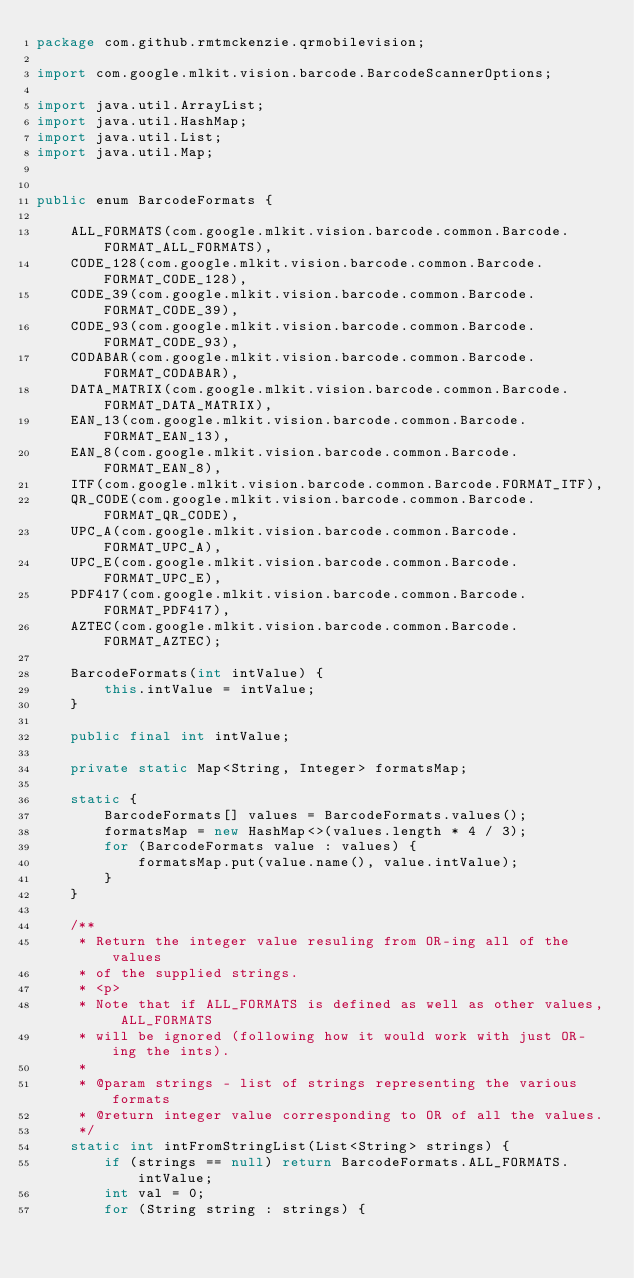<code> <loc_0><loc_0><loc_500><loc_500><_Java_>package com.github.rmtmckenzie.qrmobilevision;

import com.google.mlkit.vision.barcode.BarcodeScannerOptions;

import java.util.ArrayList;
import java.util.HashMap;
import java.util.List;
import java.util.Map;


public enum BarcodeFormats {

    ALL_FORMATS(com.google.mlkit.vision.barcode.common.Barcode.FORMAT_ALL_FORMATS),
    CODE_128(com.google.mlkit.vision.barcode.common.Barcode.FORMAT_CODE_128),
    CODE_39(com.google.mlkit.vision.barcode.common.Barcode.FORMAT_CODE_39),
    CODE_93(com.google.mlkit.vision.barcode.common.Barcode.FORMAT_CODE_93),
    CODABAR(com.google.mlkit.vision.barcode.common.Barcode.FORMAT_CODABAR),
    DATA_MATRIX(com.google.mlkit.vision.barcode.common.Barcode.FORMAT_DATA_MATRIX),
    EAN_13(com.google.mlkit.vision.barcode.common.Barcode.FORMAT_EAN_13),
    EAN_8(com.google.mlkit.vision.barcode.common.Barcode.FORMAT_EAN_8),
    ITF(com.google.mlkit.vision.barcode.common.Barcode.FORMAT_ITF),
    QR_CODE(com.google.mlkit.vision.barcode.common.Barcode.FORMAT_QR_CODE),
    UPC_A(com.google.mlkit.vision.barcode.common.Barcode.FORMAT_UPC_A),
    UPC_E(com.google.mlkit.vision.barcode.common.Barcode.FORMAT_UPC_E),
    PDF417(com.google.mlkit.vision.barcode.common.Barcode.FORMAT_PDF417),
    AZTEC(com.google.mlkit.vision.barcode.common.Barcode.FORMAT_AZTEC);

    BarcodeFormats(int intValue) {
        this.intValue = intValue;
    }

    public final int intValue;

    private static Map<String, Integer> formatsMap;

    static {
        BarcodeFormats[] values = BarcodeFormats.values();
        formatsMap = new HashMap<>(values.length * 4 / 3);
        for (BarcodeFormats value : values) {
            formatsMap.put(value.name(), value.intValue);
        }
    }

    /**
     * Return the integer value resuling from OR-ing all of the values
     * of the supplied strings.
     * <p>
     * Note that if ALL_FORMATS is defined as well as other values, ALL_FORMATS
     * will be ignored (following how it would work with just OR-ing the ints).
     *
     * @param strings - list of strings representing the various formats
     * @return integer value corresponding to OR of all the values.
     */
    static int intFromStringList(List<String> strings) {
        if (strings == null) return BarcodeFormats.ALL_FORMATS.intValue;
        int val = 0;
        for (String string : strings) {</code> 